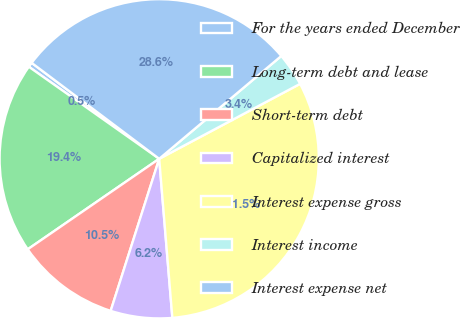Convert chart. <chart><loc_0><loc_0><loc_500><loc_500><pie_chart><fcel>For the years ended December<fcel>Long-term debt and lease<fcel>Short-term debt<fcel>Capitalized interest<fcel>Interest expense gross<fcel>Interest income<fcel>Interest expense net<nl><fcel>0.48%<fcel>19.38%<fcel>10.49%<fcel>6.23%<fcel>31.47%<fcel>3.36%<fcel>28.6%<nl></chart> 